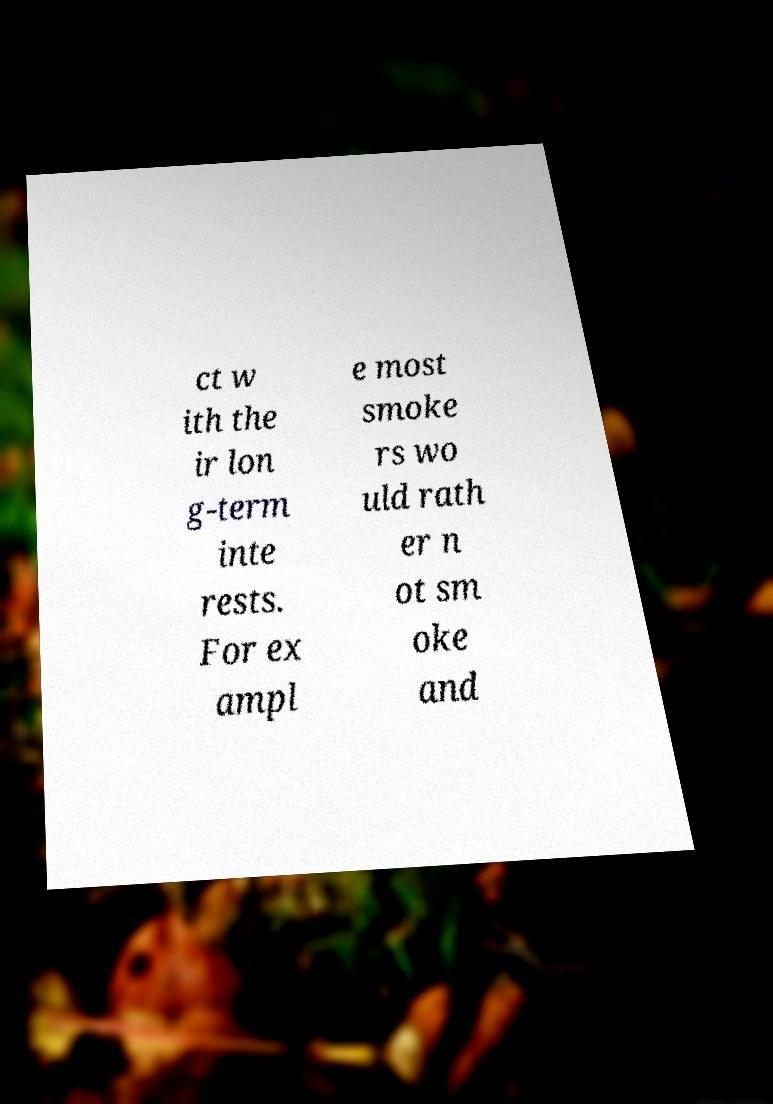What messages or text are displayed in this image? I need them in a readable, typed format. ct w ith the ir lon g-term inte rests. For ex ampl e most smoke rs wo uld rath er n ot sm oke and 